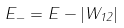Convert formula to latex. <formula><loc_0><loc_0><loc_500><loc_500>E _ { - } = E - | W _ { 1 2 } |</formula> 